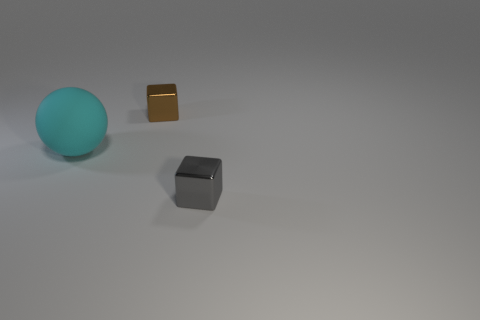There is a small block that is behind the shiny block on the right side of the shiny block behind the large object; what is it made of?
Offer a very short reply. Metal. Is there anything else that has the same material as the big cyan thing?
Make the answer very short. No. Does the brown block have the same size as the block in front of the tiny brown metallic thing?
Offer a very short reply. Yes. What number of objects are either cubes that are on the left side of the gray cube or small objects that are behind the big matte sphere?
Offer a terse response. 1. What is the color of the thing behind the big cyan matte ball?
Provide a succinct answer. Brown. Is there a brown block that is in front of the metal thing that is behind the cyan matte ball?
Your answer should be compact. No. Are there fewer brown cubes than small cyan blocks?
Your answer should be very brief. No. What is the object left of the tiny metallic thing behind the large cyan sphere made of?
Offer a terse response. Rubber. Does the brown cube have the same size as the gray cube?
Provide a short and direct response. Yes. What number of objects are cyan rubber things or big cyan cubes?
Provide a short and direct response. 1. 